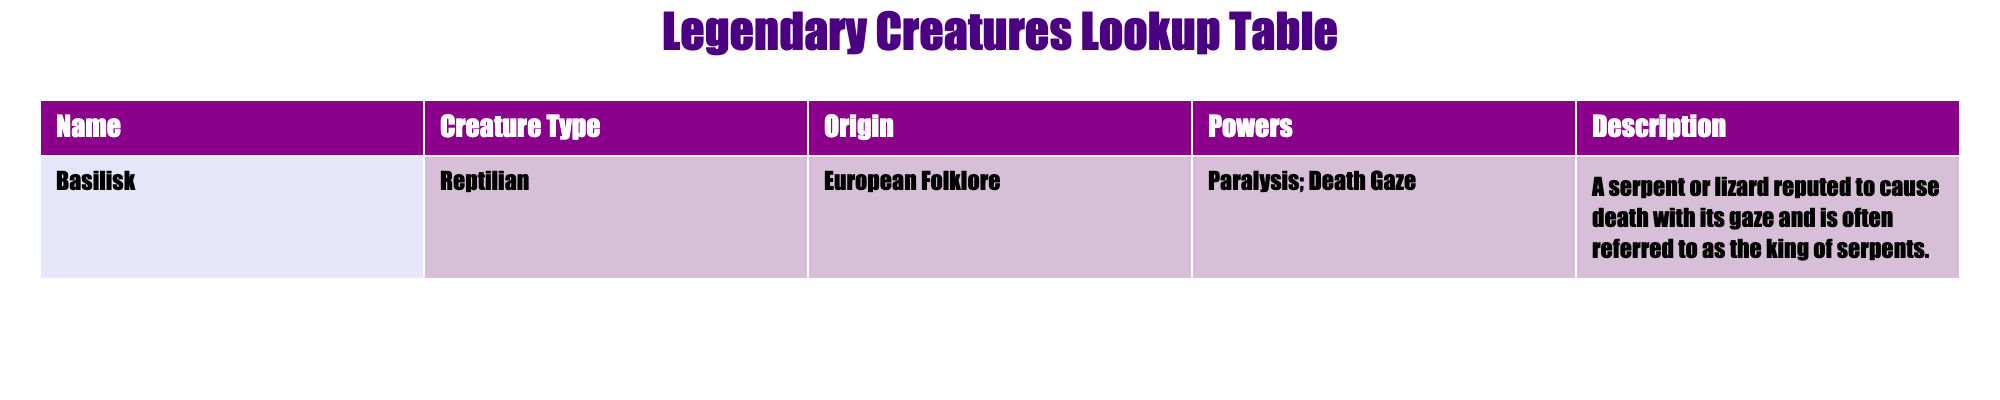What is the creature type of the Basilisk? The table lists creature types under the "Creature Type" column, where the Basilisk is specifically categorized as "Reptilian."
Answer: Reptilian Where does the Basilisk originate from? The table provides the origin of each creature in the "Origin" column, indicating that the Basilisk comes from "European Folklore."
Answer: European Folklore What unique power does the Basilisk possess? According to the "Powers" column in the table, the Basilisk is noted for having the unique ability of "Paralysis; Death Gaze."
Answer: Paralysis; Death Gaze Is the Basilisk considered to be dangerous according to its description? Evaluating the description of the Basilisk, which mentions it reputedly causes death with its gaze, can lead to the conclusion that it is indeed dangerous.
Answer: Yes If a creature is referred to as the "king of serpents," which creature is being described? In the "Description" column of the table, it is stated that the Basilisk is often referred to as the "king of serpents," making it the focus of this question.
Answer: Basilisk What powers would you need to defeat a creature that has the ability to cause paralysis and death? Considering that the Basilisk can cause paralysis and death, it would require powers of protection or counter-efficiencies that either negate its gaze or provide immunity to its effects.
Answer: Powers of protection or immunity How many powers are listed for the Basilisk, and what are they? The "Powers" column only lists one power for the Basilisk, which are "Paralysis; Death Gaze." Since there's only one unique power mentioned, the quantity is one.
Answer: One power: Paralysis; Death Gaze What type of folklore encompasses the Basilisk? The origin listed in the table concerns itself with European folklore, indicating that the Basilisk is part of this specific tradition.
Answer: European Folklore Does the table provide information about any other legendary creatures? The current table only contains data for the Basilisk and does not mention or describe any other creatures, therefore there is no information provided about others.
Answer: No 